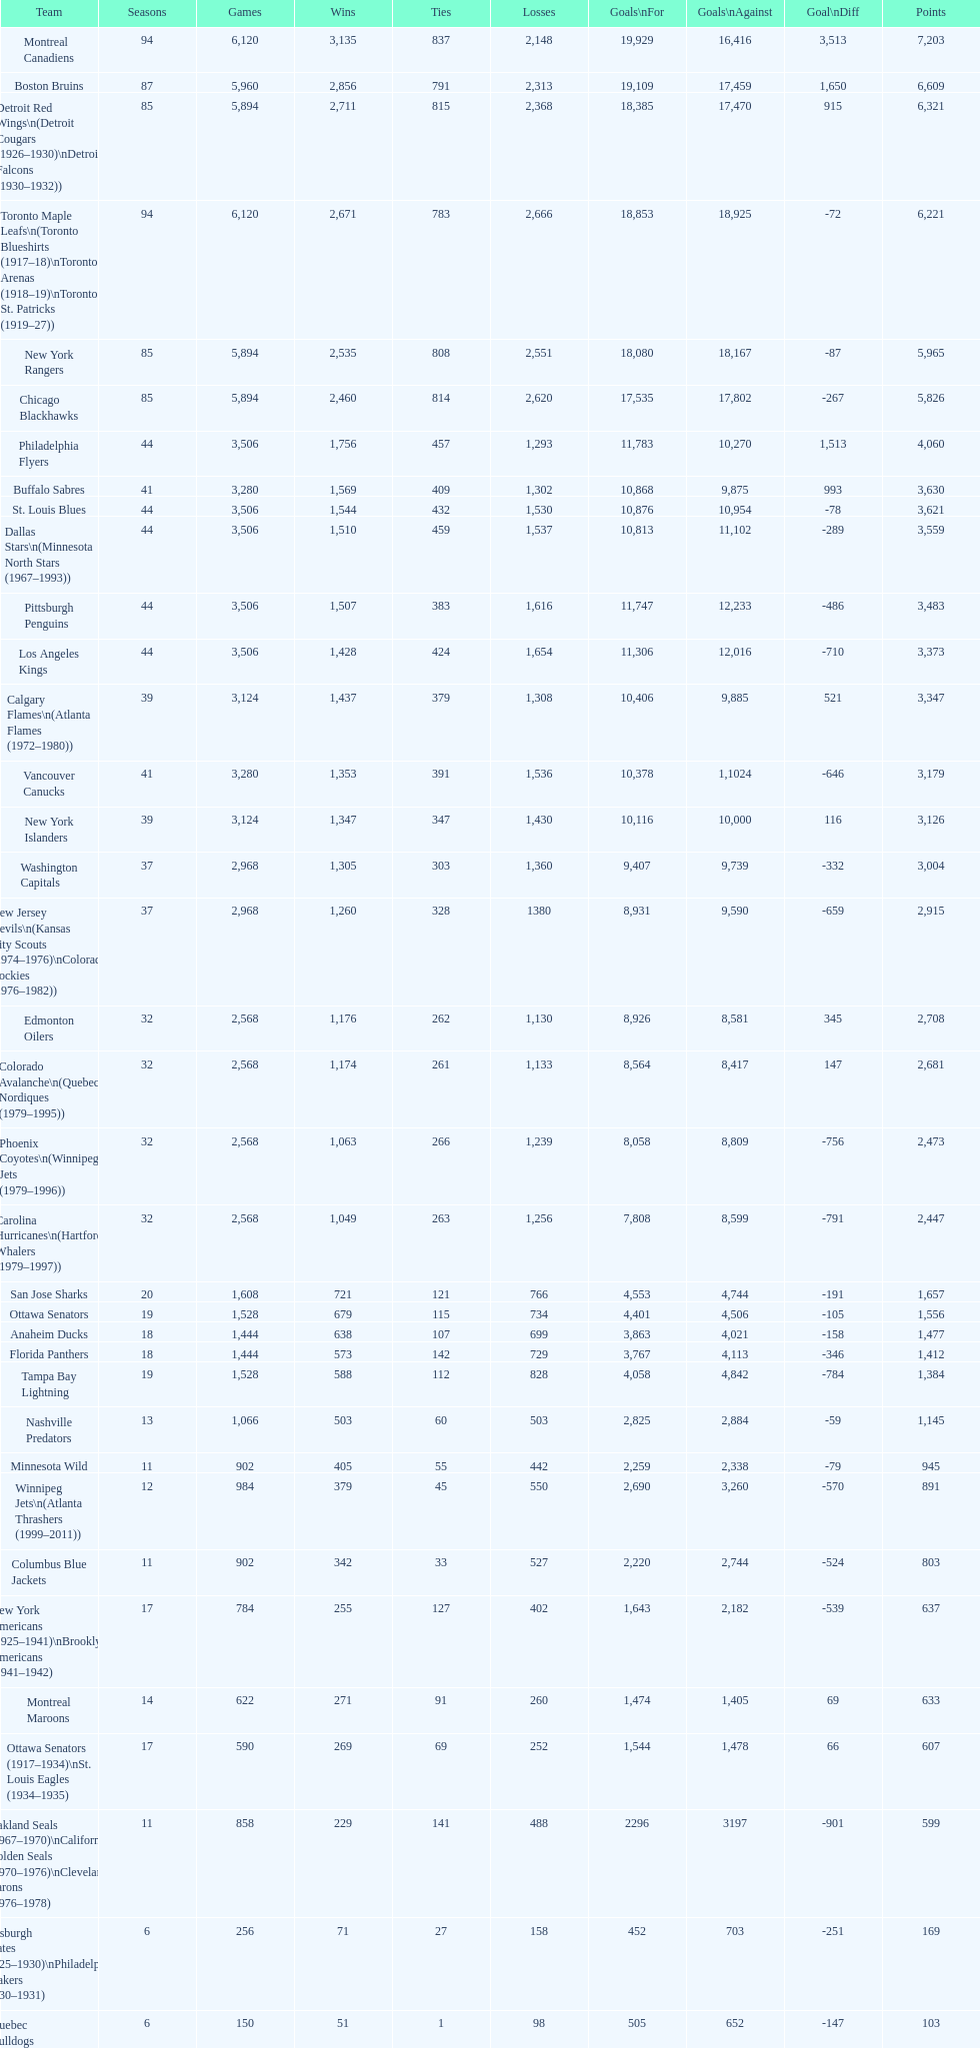Which team was last in terms of points up until this point? Montreal Wanderers. 